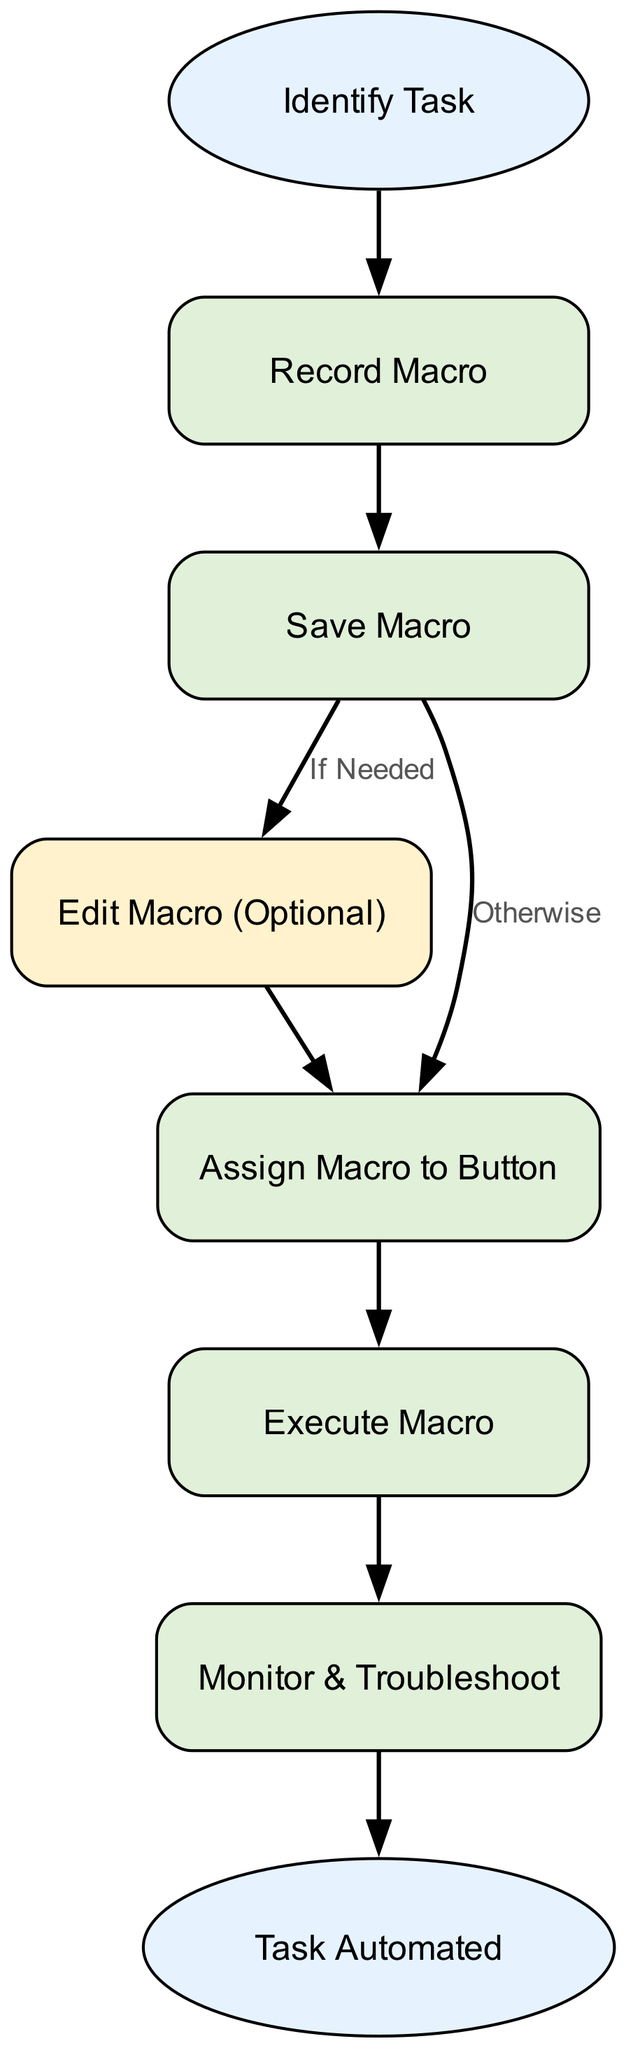What is the first step in the automation process? The first step is 'Identify Task', as indicated by the first node in the diagram from which all other steps originate.
Answer: Identify Task How many total nodes are in the diagram? Counting all nodes listed in the data provided, there are 8 nodes in total, including both the start and end nodes.
Answer: 8 What action follows 'Save Macro' if the editing is needed? If editing is needed, the next action is 'Edit Macro (Optional)', which directly follows the 'Save Macro' node.
Answer: Edit Macro (Optional) What is the final outcome of the automation process? The final outcome as depicted in the last node of the diagram is 'Task Automated'.
Answer: Task Automated Which node comes immediately after 'Run Macro'? The node that comes immediately after 'Run Macro' is 'Monitor & Troubleshoot'.
Answer: Monitor & Troubleshoot What is the purpose of the 'Edit Macro (Optional)' node? The purpose of 'Edit Macro (Optional)' is to indicate that this step is only necessary based on user needs after saving the macro.
Answer: Optional editing What happens if no edits are required after saving the macro? If no edits are required, the next step after 'Save Macro' is 'Assign Macro to Button', showing the flow of the automation process without editing.
Answer: Assign Macro to Button How many edges connect the nodes in the diagram? There are 7 edges connecting the nodes, as indicated by the relationships between the nodes in the edges data.
Answer: 7 